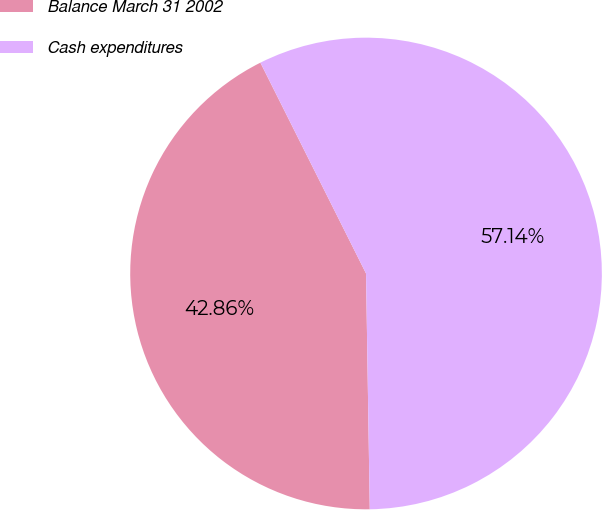<chart> <loc_0><loc_0><loc_500><loc_500><pie_chart><fcel>Balance March 31 2002<fcel>Cash expenditures<nl><fcel>42.86%<fcel>57.14%<nl></chart> 